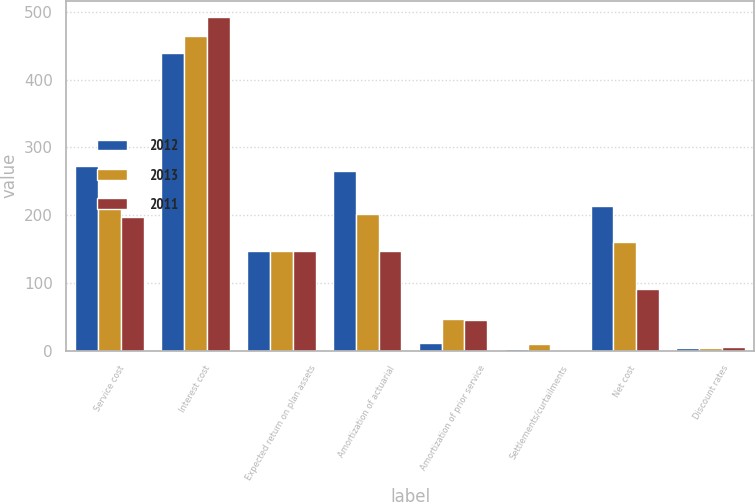Convert chart to OTSL. <chart><loc_0><loc_0><loc_500><loc_500><stacked_bar_chart><ecel><fcel>Service cost<fcel>Interest cost<fcel>Expected return on plan assets<fcel>Amortization of actuarial<fcel>Amortization of prior service<fcel>Settlements/curtailments<fcel>Net cost<fcel>Discount rates<nl><fcel>2012<fcel>273<fcel>439<fcel>148<fcel>265<fcel>12<fcel>2<fcel>213<fcel>3.8<nl><fcel>2013<fcel>220<fcel>465<fcel>148<fcel>202<fcel>47<fcel>10<fcel>160<fcel>4.4<nl><fcel>2011<fcel>197<fcel>492<fcel>148<fcel>148<fcel>46<fcel>1<fcel>91<fcel>5<nl></chart> 